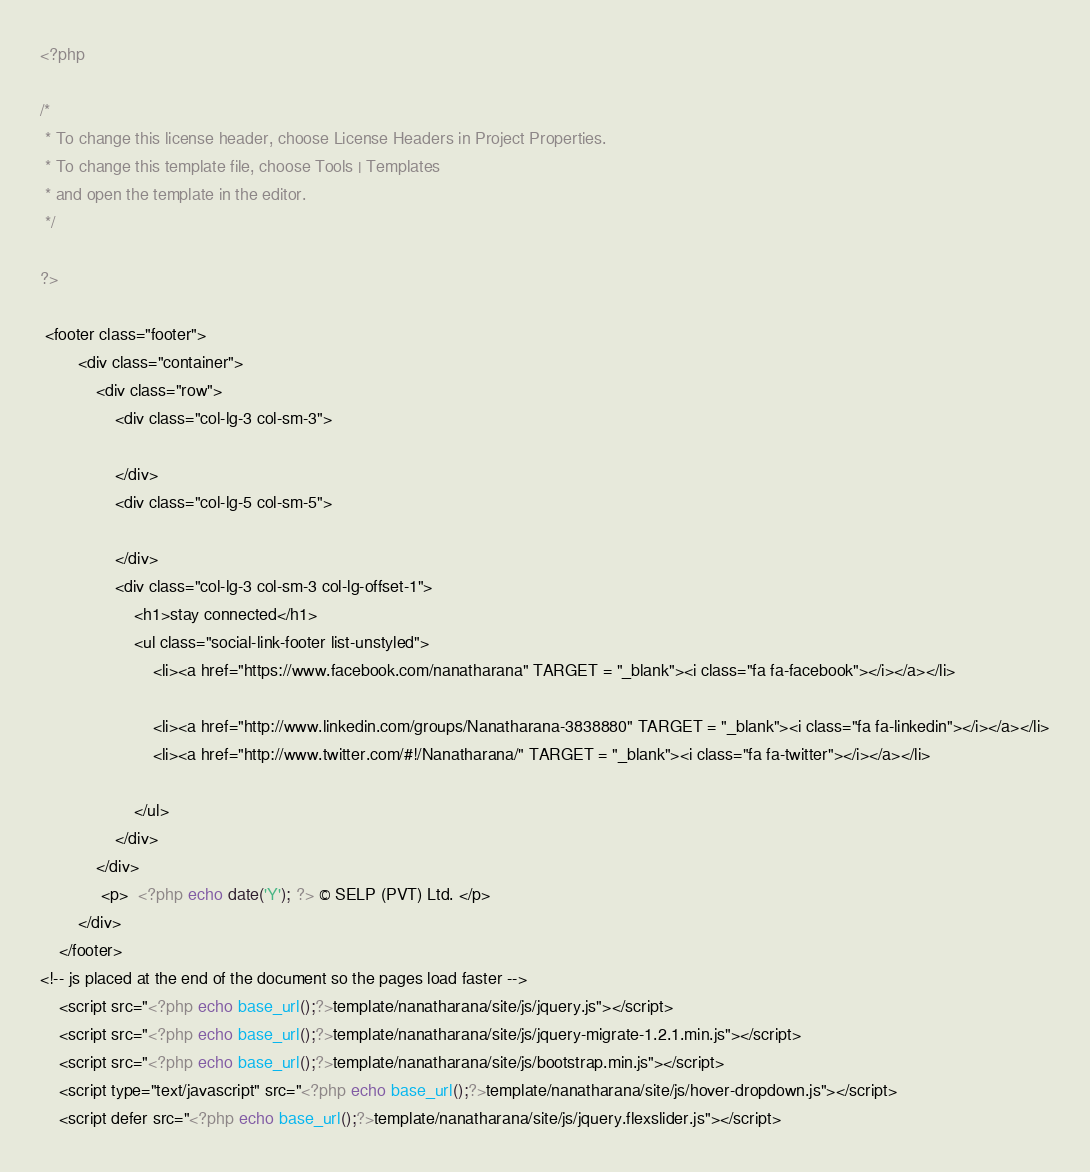Convert code to text. <code><loc_0><loc_0><loc_500><loc_500><_PHP_><?php

/* 
 * To change this license header, choose License Headers in Project Properties.
 * To change this template file, choose Tools | Templates
 * and open the template in the editor.
 */

?>

 <footer class="footer">
        <div class="container">
            <div class="row">
                <div class="col-lg-3 col-sm-3">
                   
                </div>
                <div class="col-lg-5 col-sm-5">
                    
                </div>
                <div class="col-lg-3 col-sm-3 col-lg-offset-1">
                    <h1>stay connected</h1>
                    <ul class="social-link-footer list-unstyled">
                        <li><a href="https://www.facebook.com/nanatharana" TARGET = "_blank"><i class="fa fa-facebook"></i></a></li>
                                             
                        <li><a href="http://www.linkedin.com/groups/Nanatharana-3838880" TARGET = "_blank"><i class="fa fa-linkedin"></i></a></li>
                        <li><a href="http://www.twitter.com/#!/Nanatharana/" TARGET = "_blank"><i class="fa fa-twitter"></i></a></li>                       
                       
                    </ul>
                </div>
            </div>
			 <p>  <?php echo date('Y'); ?> © SELP (PVT) Ltd. </p>
        </div>
    </footer>
<!-- js placed at the end of the document so the pages load faster -->
    <script src="<?php echo base_url();?>template/nanatharana/site/js/jquery.js"></script>
    <script src="<?php echo base_url();?>template/nanatharana/site/js/jquery-migrate-1.2.1.min.js"></script>
    <script src="<?php echo base_url();?>template/nanatharana/site/js/bootstrap.min.js"></script>
    <script type="text/javascript" src="<?php echo base_url();?>template/nanatharana/site/js/hover-dropdown.js"></script>
    <script defer src="<?php echo base_url();?>template/nanatharana/site/js/jquery.flexslider.js"></script></code> 